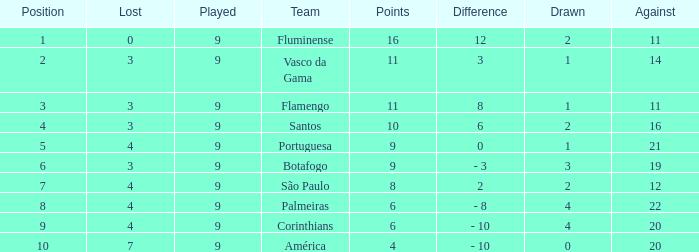Which Position has a Played larger than 9? None. 